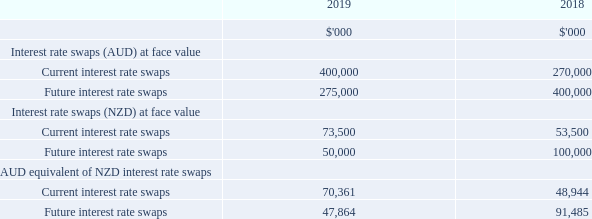Interest rate swaps
The Group has the following interest rate swaps in place as at the end of the reporting period:
Future interest rate swaps in place at the end of the reporting period have maturity dates ranging from 23 September 2019 to 23 September 2026 (2018: 24 September 2018 to 23 September 2026).
On 24 June 2019, the Group reset the interest rates associated with AUD denominated interest rate swaps. This resulted in a cash outflow of $22.9m which reduced the Group’s financial liability presented in note 9.8. The cumulative change in fair value of these hedging instruments is carried in a separate reserve in equity (cash flow hedge reserve of NSPT presented within non-controlling interest in the Group’s consolidated statement of changes in equity).
This balance will be recycled from the hedge reserve to finance costs in the statement of profit and loss in future reporting periods corresponding to when the underlying hedged item impacts profit or loss. For the year ended 30 June 2019, $0.1m has been recognised in finance costs relating to this item.
What is the range of maturity dates of Future interest rate swaps in 2018? 24 september 2018 to 23 september 2026. When did the Group reset the interest rates associated with AUD denominated interest rate swaps? 24 june 2019. Where is the cumulative change in fair value of hedging instruments carried? In a separate reserve in equity (cash flow hedge reserve of nspt presented within non-controlling interest in the group’s consolidated statement of changes in equity). What is the change in Interest rate swaps (AUD) at face value for Current interest rate swaps from 2018 to 2019?
Answer scale should be: thousand. 400,000-270,000
Answer: 130000. What is the change in Interest rate swaps (AUD) at face value for Future interest rate swaps from 2018 to 2019?
Answer scale should be: thousand. 275,000-400,000
Answer: -125000. What is the change in Interest rate swaps (NZD) at face value for Current interest rate swaps from 2018 to 2019?
Answer scale should be: thousand. 73,500-53,500
Answer: 20000. 